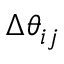Convert formula to latex. <formula><loc_0><loc_0><loc_500><loc_500>\Delta \theta _ { i j }</formula> 